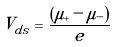Convert formula to latex. <formula><loc_0><loc_0><loc_500><loc_500>V _ { d s } = \frac { ( \mu _ { + } - \mu _ { - } ) } { e }</formula> 